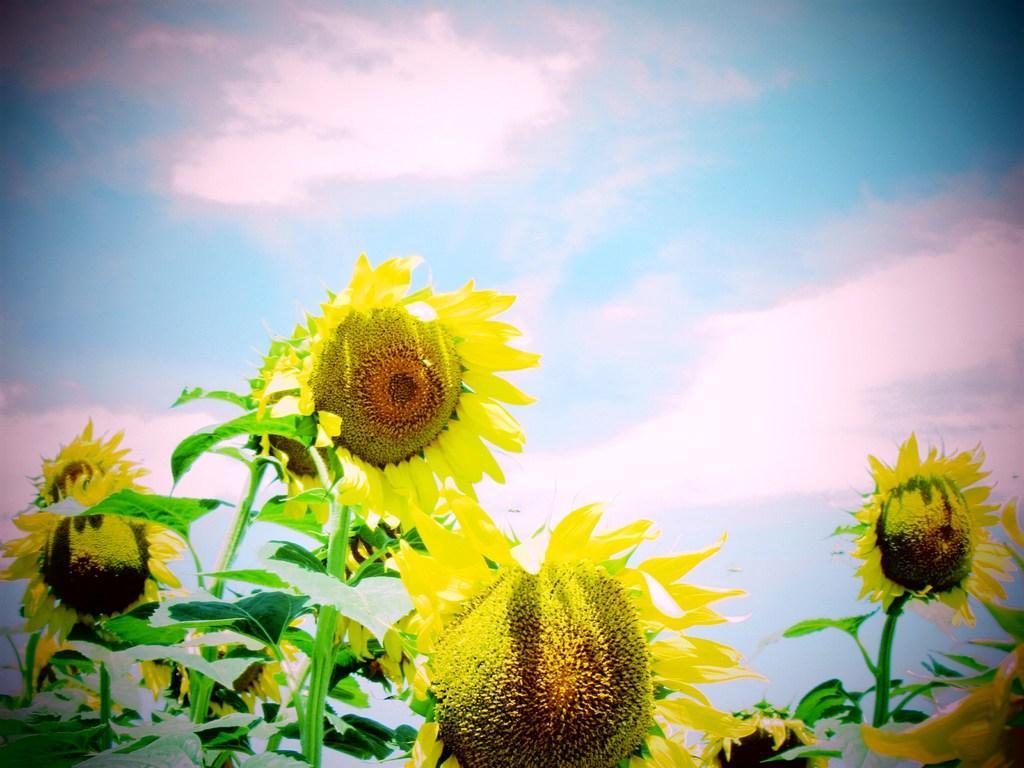Describe this image in one or two sentences. There are plants having yellow color sunflowers and green color leaves. In the background, there are clouds in the blue sky. 